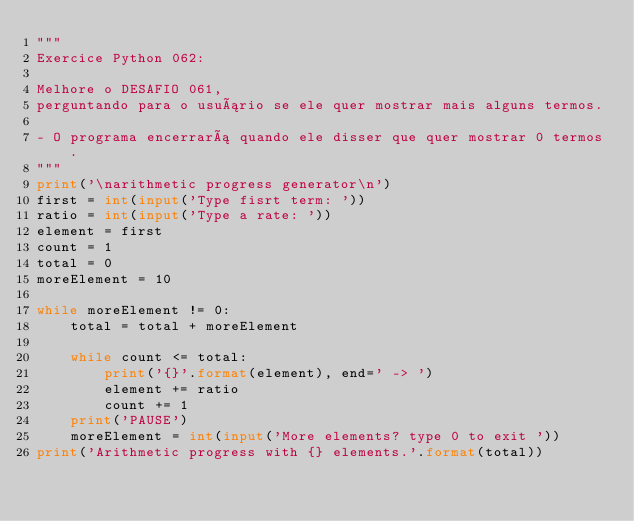<code> <loc_0><loc_0><loc_500><loc_500><_Python_>"""
Exercice Python 062:

Melhore o DESAFIO 061,
perguntando para o usuário se ele quer mostrar mais alguns termos.

- O programa encerrará quando ele disser que quer mostrar 0 termos.
"""
print('\narithmetic progress generator\n')
first = int(input('Type fisrt term: '))
ratio = int(input('Type a rate: '))
element = first
count = 1
total = 0
moreElement = 10

while moreElement != 0:
    total = total + moreElement

    while count <= total:
        print('{}'.format(element), end=' -> ')
        element += ratio
        count += 1
    print('PAUSE')
    moreElement = int(input('More elements? type 0 to exit '))
print('Arithmetic progress with {} elements.'.format(total))
</code> 